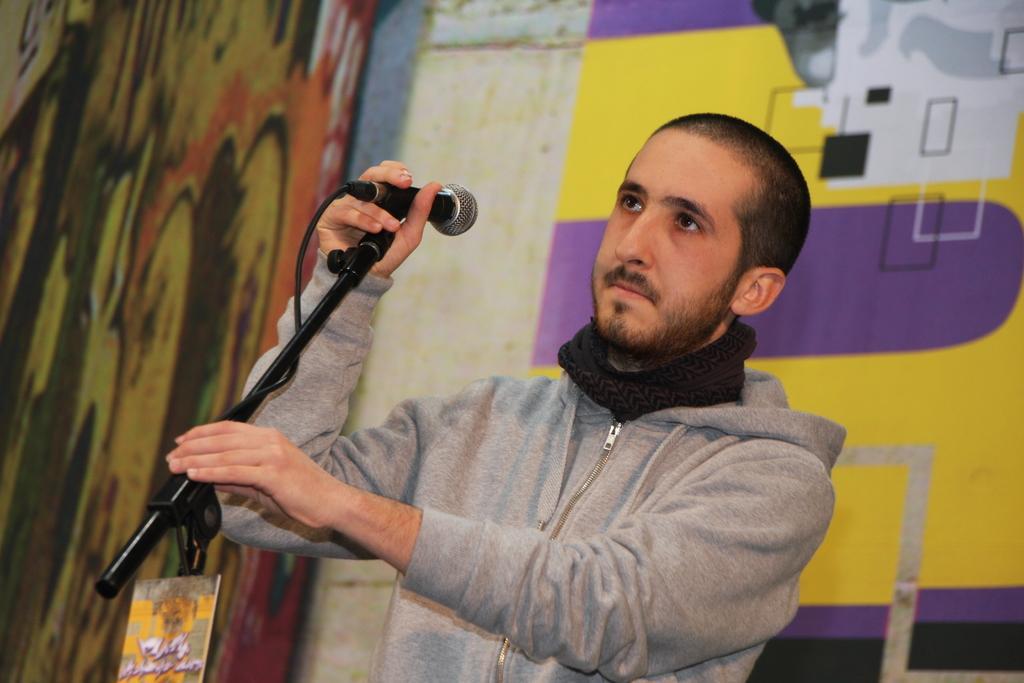Can you describe this image briefly? In this image can see a man wearing jacket and holding a mike in his hands and looking at the left side. In the background there is a wall. 